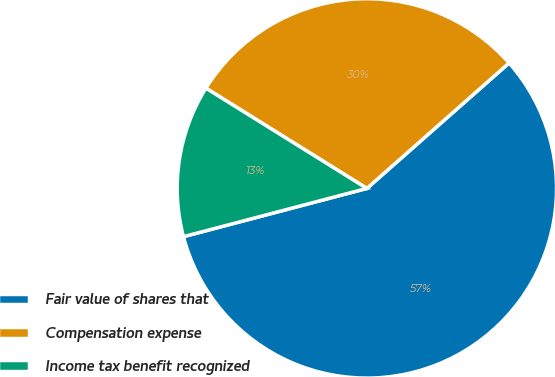<chart> <loc_0><loc_0><loc_500><loc_500><pie_chart><fcel>Fair value of shares that<fcel>Compensation expense<fcel>Income tax benefit recognized<nl><fcel>57.41%<fcel>29.63%<fcel>12.96%<nl></chart> 